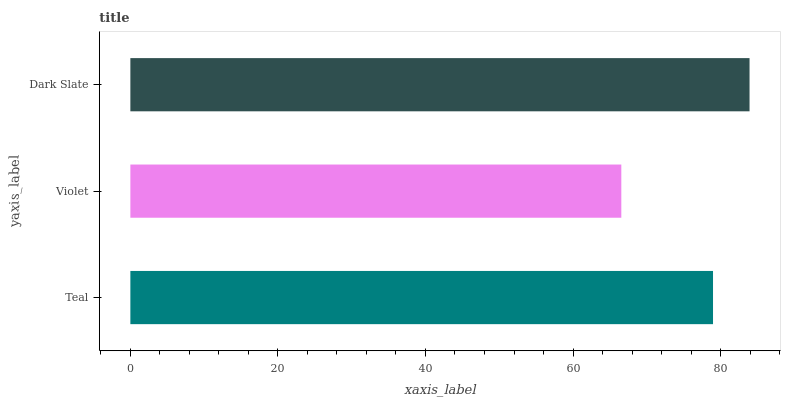Is Violet the minimum?
Answer yes or no. Yes. Is Dark Slate the maximum?
Answer yes or no. Yes. Is Dark Slate the minimum?
Answer yes or no. No. Is Violet the maximum?
Answer yes or no. No. Is Dark Slate greater than Violet?
Answer yes or no. Yes. Is Violet less than Dark Slate?
Answer yes or no. Yes. Is Violet greater than Dark Slate?
Answer yes or no. No. Is Dark Slate less than Violet?
Answer yes or no. No. Is Teal the high median?
Answer yes or no. Yes. Is Teal the low median?
Answer yes or no. Yes. Is Violet the high median?
Answer yes or no. No. Is Violet the low median?
Answer yes or no. No. 